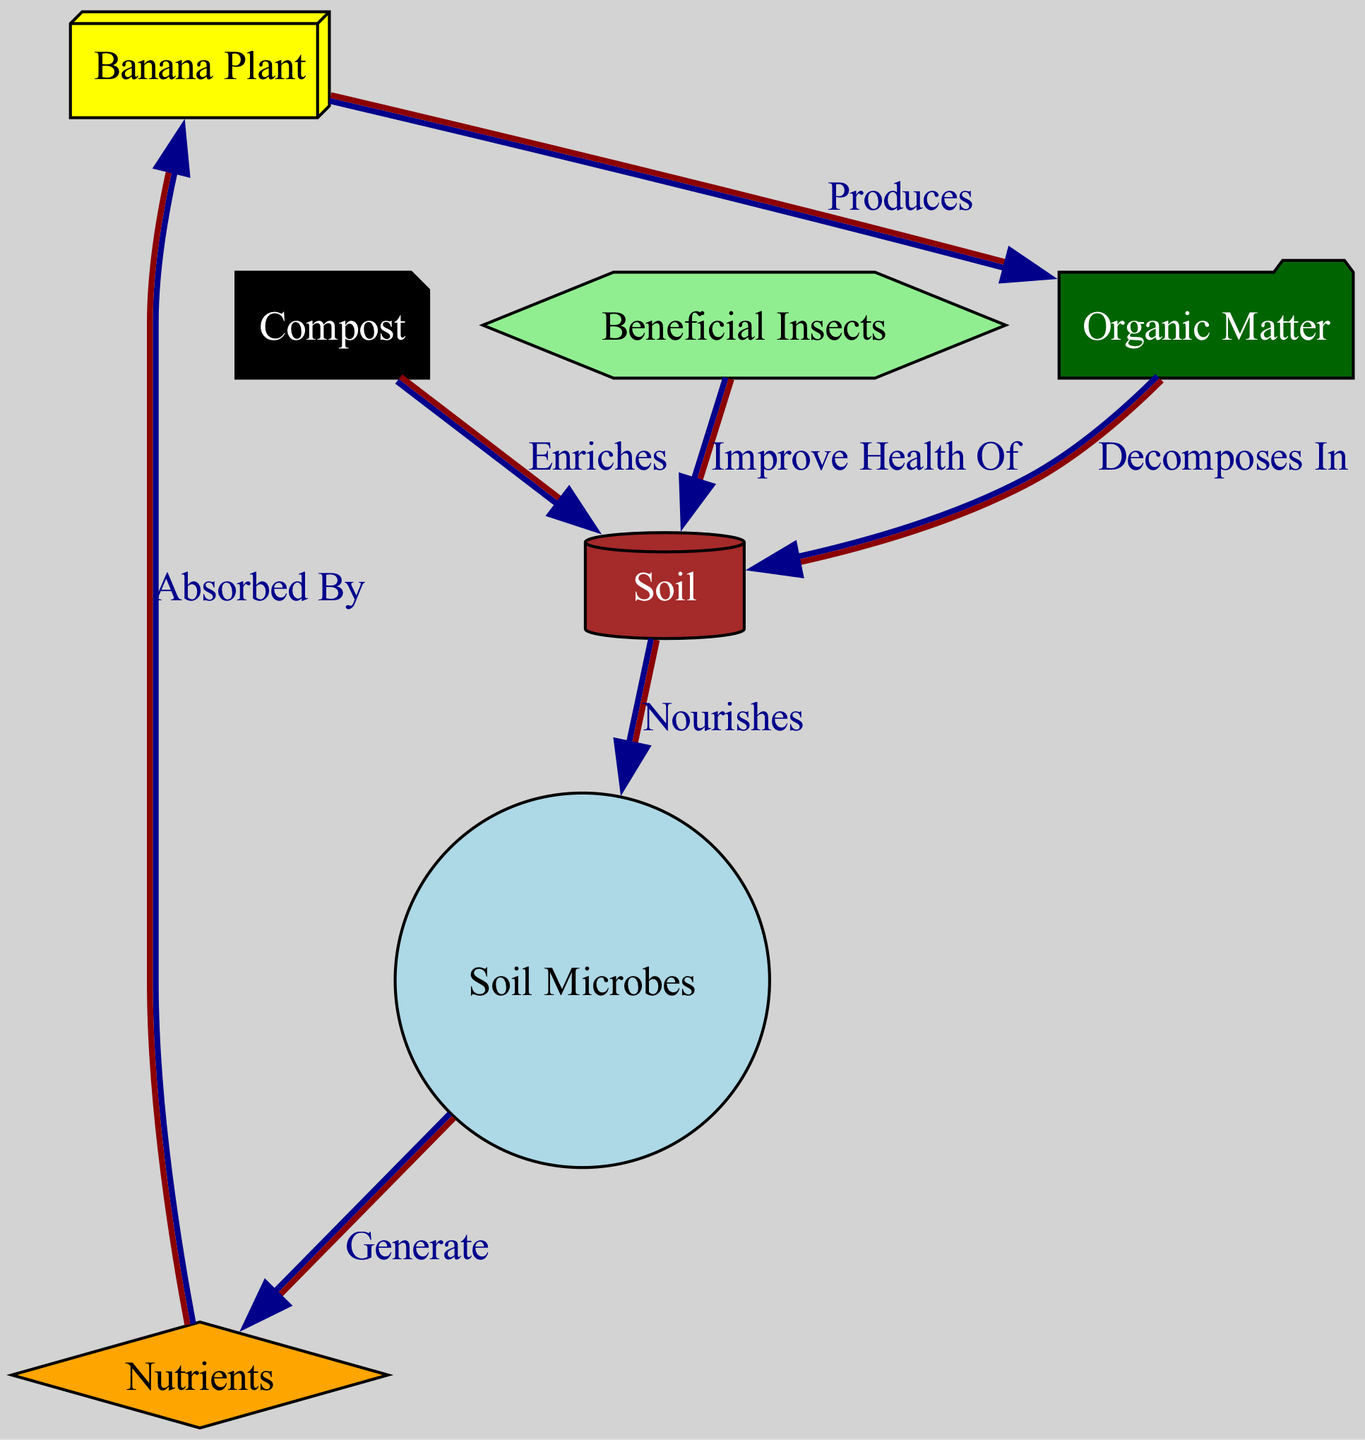What is the total number of nodes in the diagram? The diagram lists seven entities: the banana plant, soil, organic matter, soil microbes, nutrients, compost, and beneficial insects, thus totaling seven distinct nodes.
Answer: 7 What relationship does compost have with soil? The edge connecting compost to soil is labeled "Enriches," indicating that compost contributes positively to the composition or quality of the soil.
Answer: Enriches Which node produces organic matter? The banana plant is the node that, according to the diagram, produces organic matter as indicated by the directed edge labeled "Produces."
Answer: Banana Plant What do soil microbes generate? The directed edge from soil microbes to nutrients is labeled "Generate," which clearly states that soil microbes are responsible for producing or creating nutrients.
Answer: Nutrients How do beneficial insects interact with soil? According to the diagram, beneficial insects improve the health of the soil, as indicated by the edge labeled "Improve Health Of." This shows a positive relationship that likely promotes soil vitality.
Answer: Improve Health Of What is the flow of nutrients from soil to banana plant? The pathway indicates that soil nourishes soil microbes, which generate nutrients, and then these nutrients are absorbed by the banana plant, demonstrating a sequential flow from soil to the banana plant through microbes.
Answer: Soil to microbes to nutrients to banana plant What role does organic matter play in soil? Organic matter decomposes in the soil, adding nutrients and improving soil structure and fertility, as indicated by the edge labeled "Decomposes In," connecting organic matter to soil.
Answer: Decomposes In What is the main function of soil in this chain? In the diagram, the soil nourishes the soil microbes, which is a crucial function since healthy microbes are essential for nutrient generation and overall soil health, therefore supporting the whole system.
Answer: Nourishes How do nutrients reach the banana plant? Nutrients are generated by soil microbes which then flow directly to the banana plant, indicating that the health of soil microbes is essential for nutrient uptake by the plant.
Answer: Absorbed By 